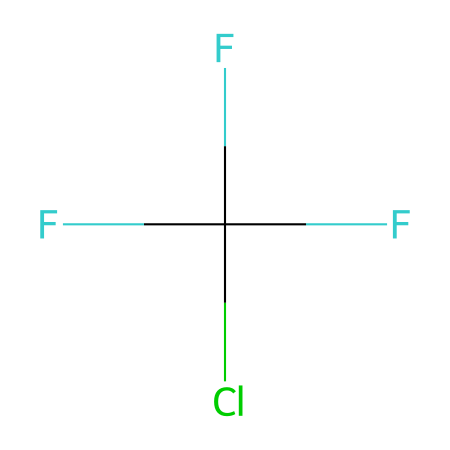What is the total number of fluorine atoms in this chemical? The SMILES representation shows "F" listed three times, indicating three fluorine atoms present in the structure.
Answer: three How many chlorine atoms does this chemical contain? The SMILES representation includes one "Cl," signifying that there is one chlorine atom in the structure.
Answer: one What type of chemical bond is primarily responsible for the stability of this molecule? The structure does not show any double or triple bonds; thus, we can infer that single covalent bonds are primarily responsible for the molecule's stability.
Answer: single How many carbon atoms are in this chemical? The SMILES representation includes no explicit carbon symbols, but it implies the presence of a carbon atom connecting the groups, indicating that there is one carbon atom.
Answer: one What is the overall classification of this compound in terms of its environmental impact? This compound is classified as a chlorofluorocarbon (CFC), which is known for its ozone-depleting properties.
Answer: chlorofluorocarbon How can the presence of chlorine influence the reactivity of this chemical? Chlorine is highly electronegative and capable of participating in reactions that break down ozone, which demonstrates its role in ozone depletion.
Answer: ozone depletion 